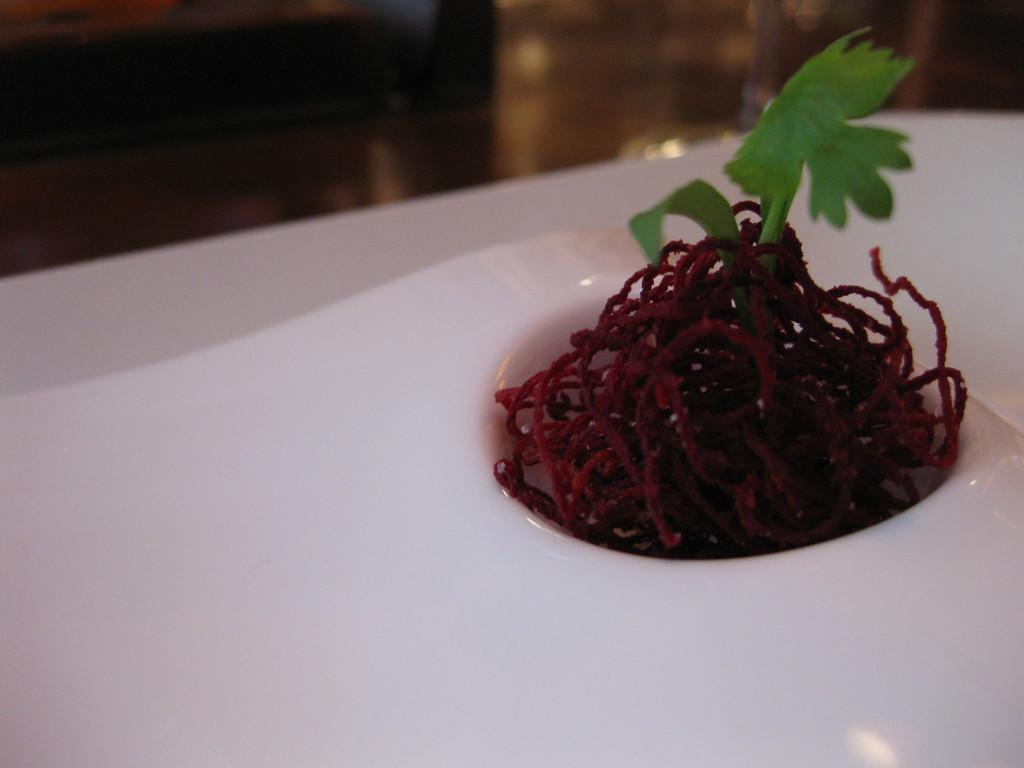What is the main subject of the image? There is a food item in the image. Can you describe the food item in more detail? The food item has a leafy vegetable on it. How many bears are sitting on the food item in the image? There are no bears present in the image; it only features a food item with a leafy vegetable on it. 